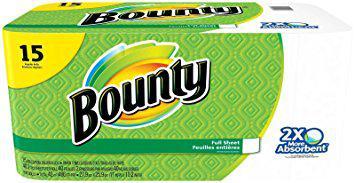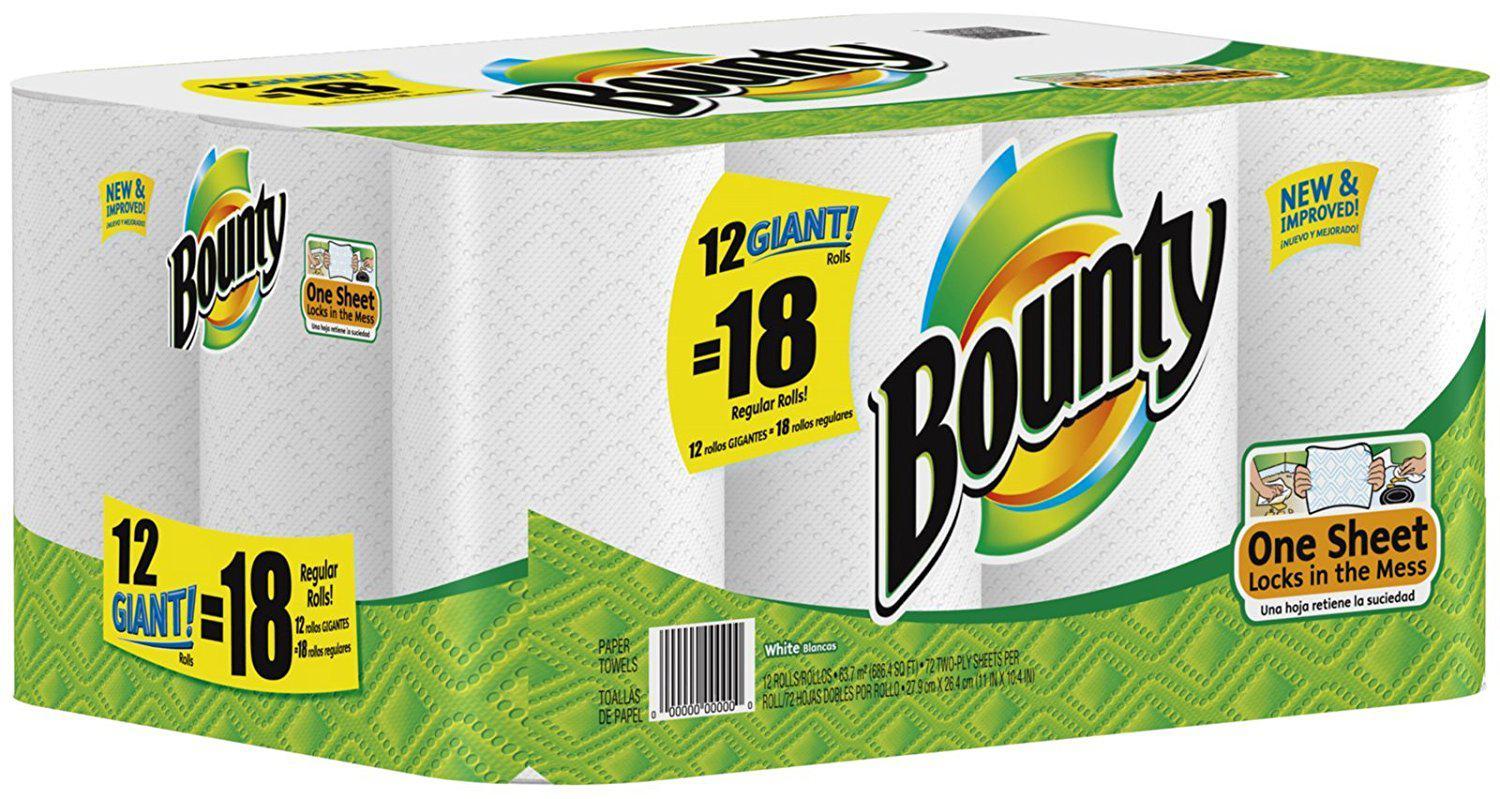The first image is the image on the left, the second image is the image on the right. For the images displayed, is the sentence "The left image shows one multi-roll package of towels with a yellow quarter circle in the upper left corner, and the package on the right features the same basic color scheme as the pack on the left." factually correct? Answer yes or no. Yes. The first image is the image on the left, the second image is the image on the right. For the images displayed, is the sentence "Every single package of paper towels claims to be 15 rolls worth." factually correct? Answer yes or no. No. The first image is the image on the left, the second image is the image on the right. Given the left and right images, does the statement "One multipack of towel rolls has a yellow semi-circle in the upper left, and the other multipack has a yellow curved shape with a double-digit number on it." hold true? Answer yes or no. Yes. The first image is the image on the left, the second image is the image on the right. Given the left and right images, does the statement "There is a package that contains larger than regular sized paper towel rolls." hold true? Answer yes or no. Yes. 